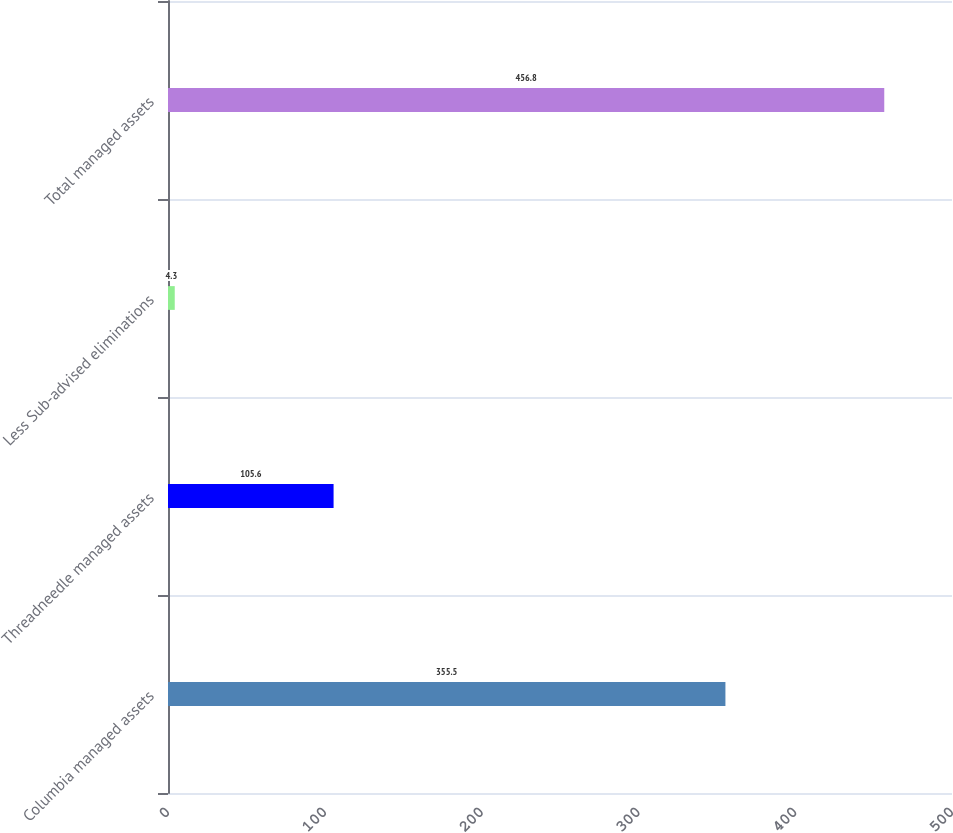Convert chart to OTSL. <chart><loc_0><loc_0><loc_500><loc_500><bar_chart><fcel>Columbia managed assets<fcel>Threadneedle managed assets<fcel>Less Sub-advised eliminations<fcel>Total managed assets<nl><fcel>355.5<fcel>105.6<fcel>4.3<fcel>456.8<nl></chart> 